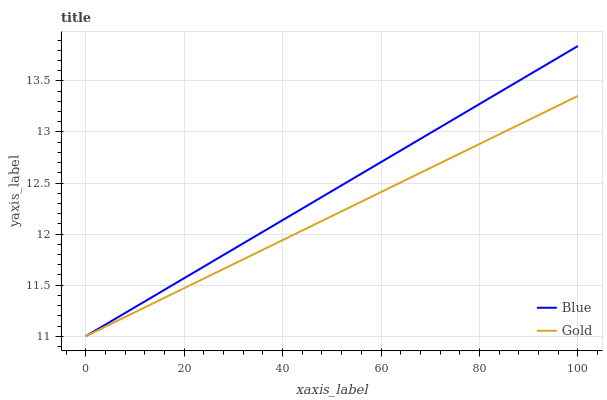Does Gold have the minimum area under the curve?
Answer yes or no. Yes. Does Blue have the maximum area under the curve?
Answer yes or no. Yes. Does Gold have the maximum area under the curve?
Answer yes or no. No. Is Gold the smoothest?
Answer yes or no. Yes. Is Blue the roughest?
Answer yes or no. Yes. Is Gold the roughest?
Answer yes or no. No. Does Blue have the lowest value?
Answer yes or no. Yes. Does Blue have the highest value?
Answer yes or no. Yes. Does Gold have the highest value?
Answer yes or no. No. Does Blue intersect Gold?
Answer yes or no. Yes. Is Blue less than Gold?
Answer yes or no. No. Is Blue greater than Gold?
Answer yes or no. No. 